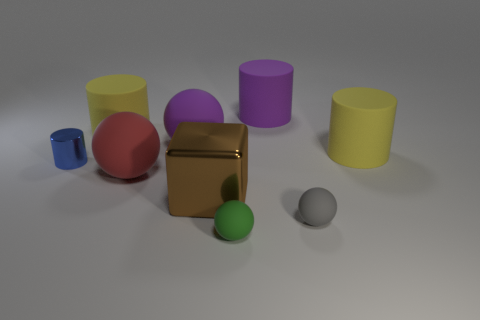Can you describe the lighting in the scene? The lighting in the scene is soft and diffused, coming from the upper left. There are subtle shadows extending to the right of the objects, suggesting a single light source that creates a calm and even tone across the composition. 